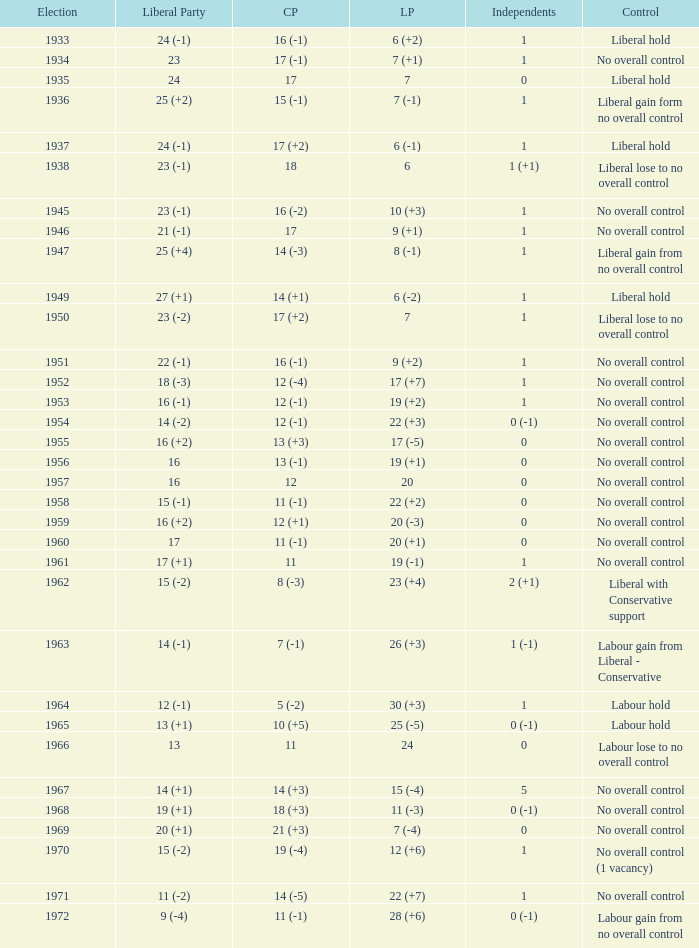What is the number of Independents elected in the year Labour won 26 (+3) seats? 1 (-1). 